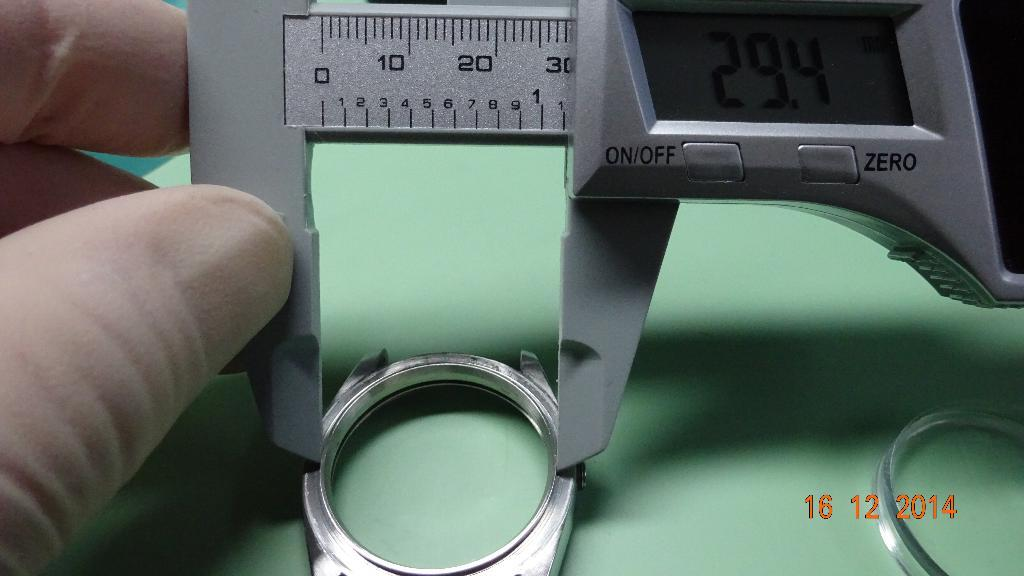<image>
Create a compact narrative representing the image presented. a measuring device reading 29.4 on its screen 